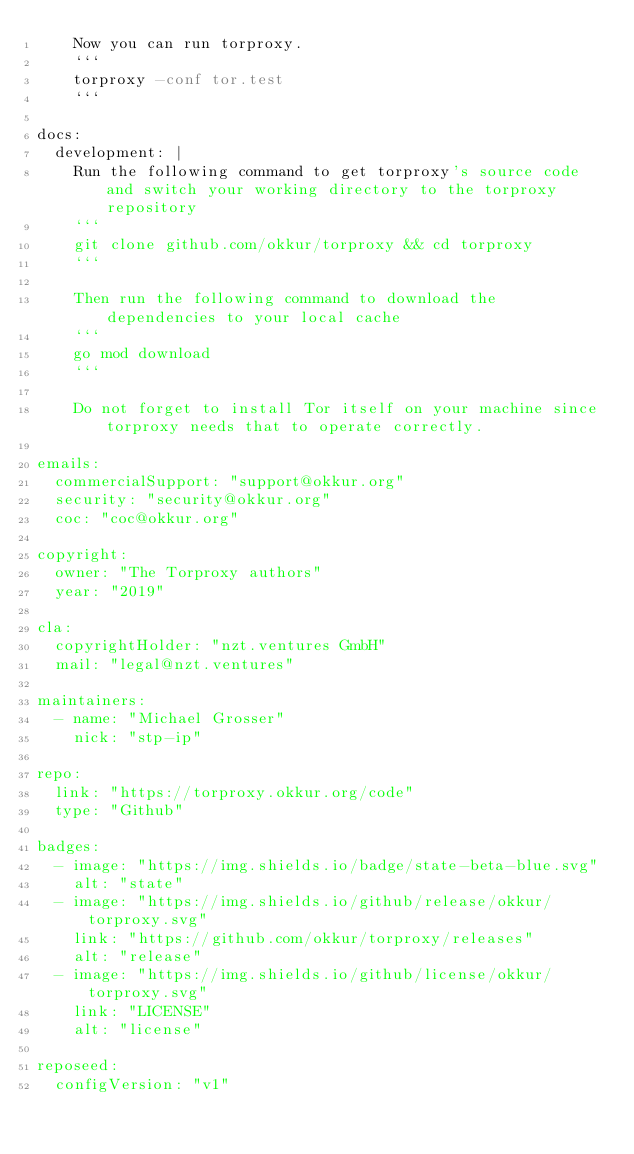Convert code to text. <code><loc_0><loc_0><loc_500><loc_500><_YAML_>    Now you can run torproxy.
    ```
    torproxy -conf tor.test
    ```

docs:
  development: |
    Run the following command to get torproxy's source code and switch your working directory to the torproxy repository
    ```
    git clone github.com/okkur/torproxy && cd torproxy
    ```

    Then run the following command to download the dependencies to your local cache
    ```
    go mod download
    ```

    Do not forget to install Tor itself on your machine since torproxy needs that to operate correctly.

emails:
  commercialSupport: "support@okkur.org"
  security: "security@okkur.org"
  coc: "coc@okkur.org"

copyright:
  owner: "The Torproxy authors"
  year: "2019"

cla:
  copyrightHolder: "nzt.ventures GmbH"
  mail: "legal@nzt.ventures"

maintainers:
  - name: "Michael Grosser"
    nick: "stp-ip"

repo:
  link: "https://torproxy.okkur.org/code"
  type: "Github"

badges:
  - image: "https://img.shields.io/badge/state-beta-blue.svg"
    alt: "state"
  - image: "https://img.shields.io/github/release/okkur/torproxy.svg"
    link: "https://github.com/okkur/torproxy/releases"
    alt: "release"
  - image: "https://img.shields.io/github/license/okkur/torproxy.svg"
    link: "LICENSE"
    alt: "license"

reposeed:
  configVersion: "v1"
</code> 